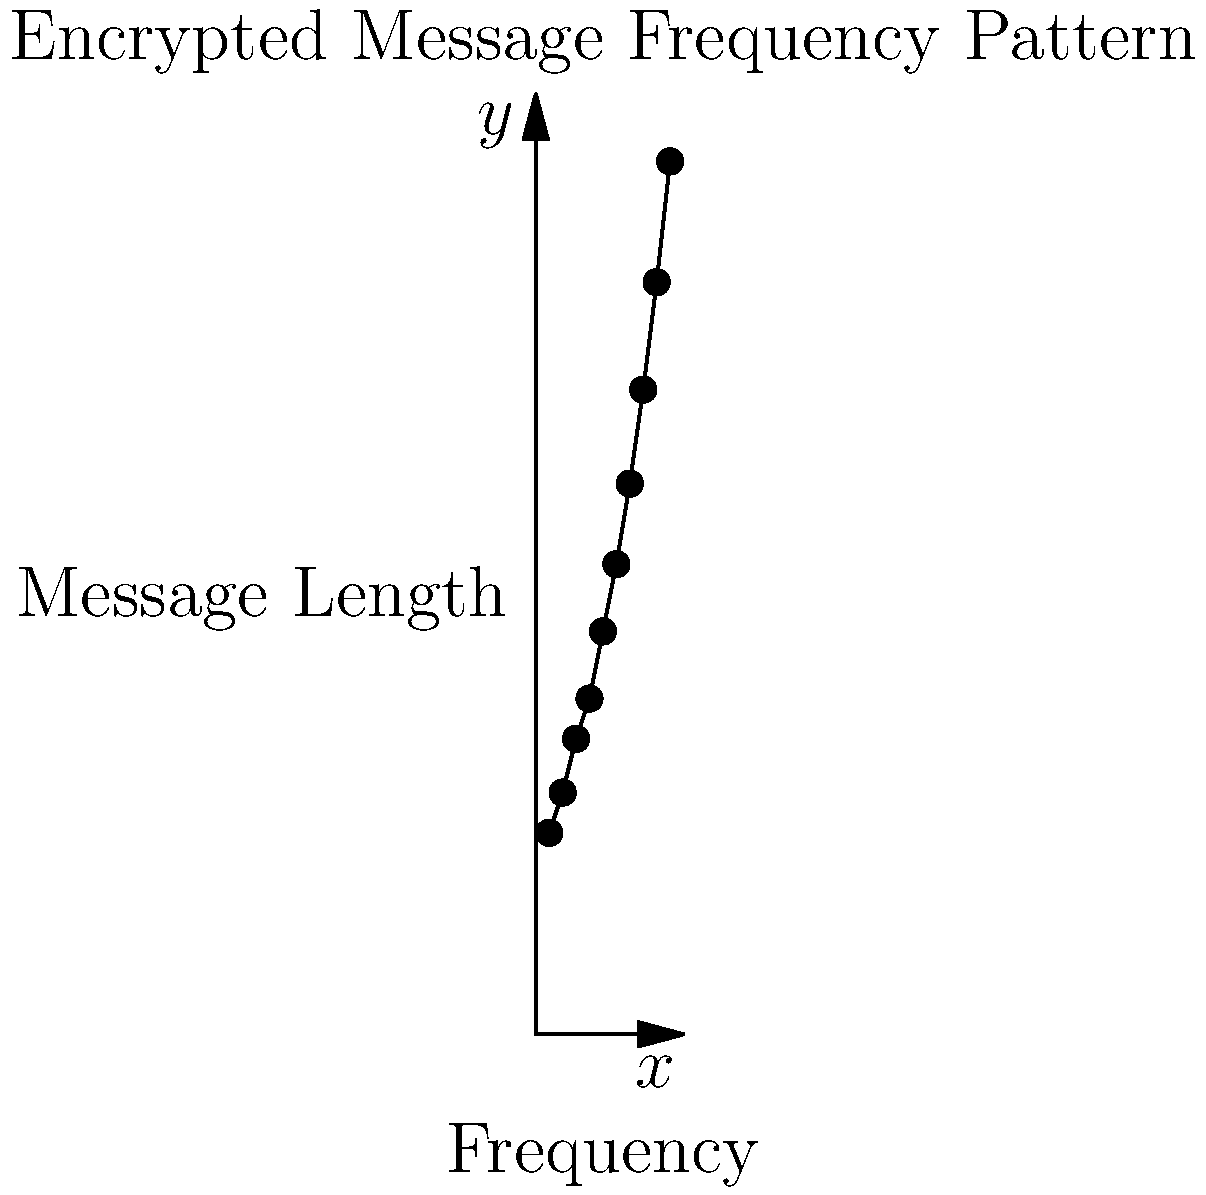Based on the scatter plot of encrypted message frequencies, what type of relationship appears to exist between message length and frequency? To determine the relationship between message length and frequency in the scatter plot, we need to analyze the pattern of the data points:

1. Observe the overall trend: As we move from left to right (increasing message length), the frequency values generally increase.

2. Examine the rate of increase: The increase in frequency is not linear. The gap between consecutive points grows larger as we move to the right.

3. Shape of the curve: The data points form a curve that bends upward, resembling an exponential or power function.

4. Steepness: The curve becomes steeper as the message length increases, indicating a faster rate of change in frequency for longer messages.

5. Consistency: There are no significant outliers or deviations from the general trend.

Given these observations, the relationship between message length and frequency appears to be exponential or following a power law. This is characteristic of many encryption algorithms, where small increases in message length can lead to disproportionately large increases in the number of possible encrypted forms.
Answer: Exponential or power law relationship 